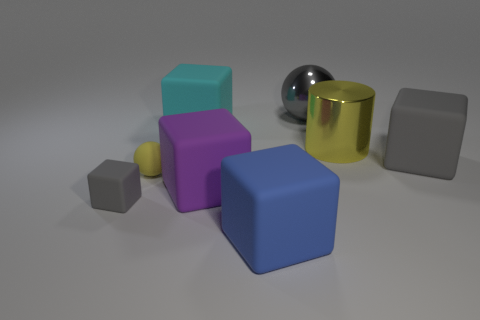Subtract all cyan cylinders. How many gray blocks are left? 2 Subtract 2 blocks. How many blocks are left? 3 Subtract all gray cubes. How many cubes are left? 3 Subtract all cyan cubes. How many cubes are left? 4 Add 1 large cubes. How many objects exist? 9 Subtract all green cubes. Subtract all cyan spheres. How many cubes are left? 5 Subtract all balls. How many objects are left? 6 Subtract all metal balls. Subtract all cyan matte objects. How many objects are left? 6 Add 1 blue blocks. How many blue blocks are left? 2 Add 4 small gray blocks. How many small gray blocks exist? 5 